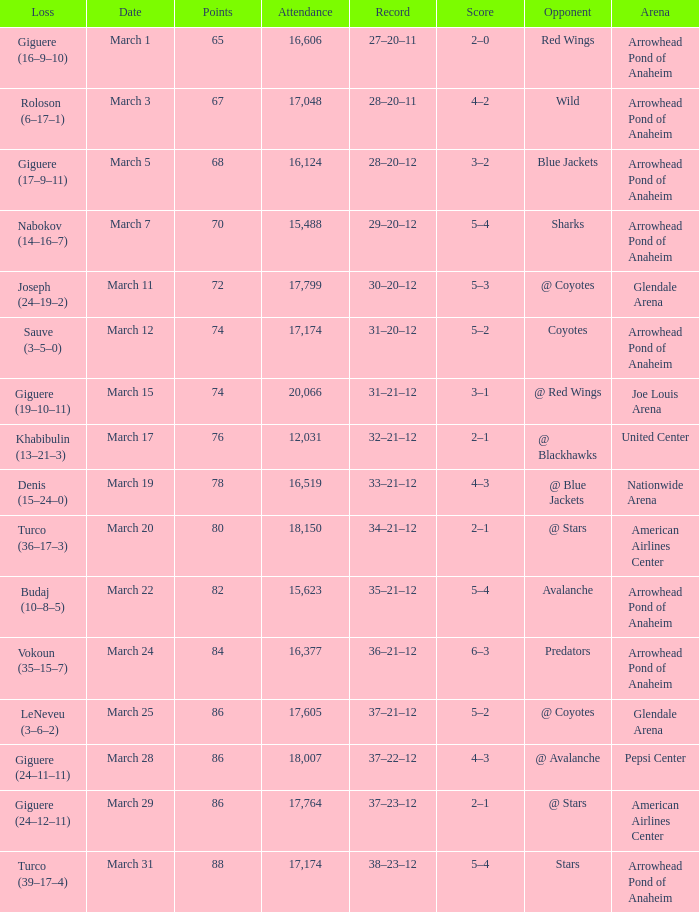What is the Attendance of the game with a Record of 37–21–12 and less than 86 Points? None. 